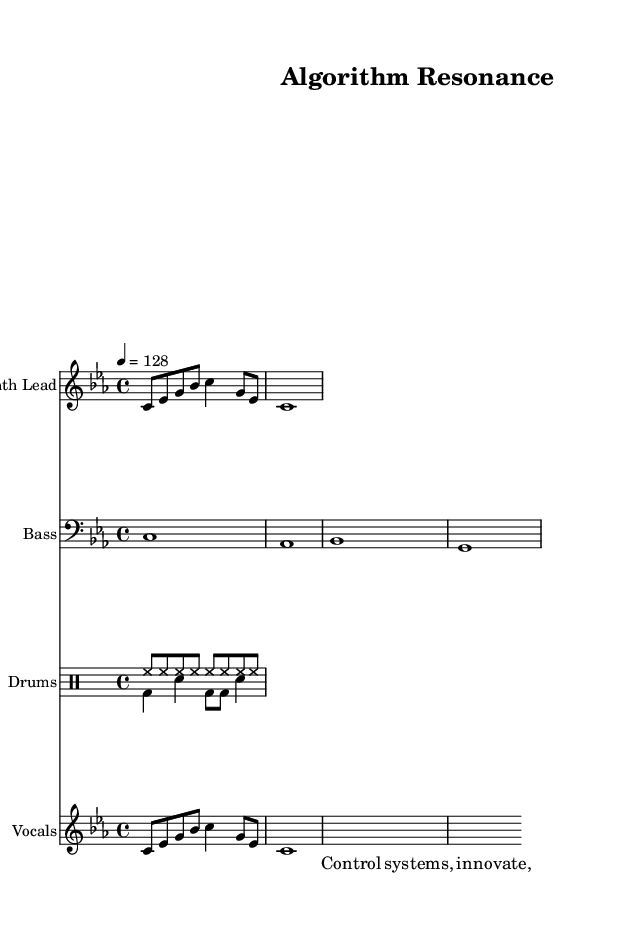What is the key signature of this music? The key signature is indicated by the presence of the flat sign on the B note, suggesting that this piece is in C minor, which has three flats (B♭, E♭, A♭).
Answer: C minor What is the time signature of this music? The time signature appears at the beginning of the score, represented by the notation '4/4', indicating four beats in each measure and a quarter note receives one beat.
Answer: 4/4 What is the tempo marking for this piece? The tempo marking is found in the score with the indication '4 = 128', meaning that there are 128 beats per minute where the quarter note gets the beat.
Answer: 128 How many measures are there in the synth lead? The synth lead section consists of two distinct measures, each with specific note values outlined in the music.
Answer: 2 What type of drum patterns are used in this piece? The score includes two separate drumming sections: 'drumsUp' contains a hi-hat rhythm while 'drumsDown' features a combination of bass drum and snare drum patterns. This highlights a typical house beat structure.
Answer: Hi-hat and bass/snare Which instrument has the main melodic theme? The synth lead, noted as the first entry and contains melody lines, carries the primary theme of this piece, establishing its character in the arrangement.
Answer: Synth Lead What are the lyrics of the robotic vocals? The robotic vocals are displayed directly in the lyrics section, stating both syllabic components and the flow within the measure to complement the rhythm and theme of innovation.
Answer: Control systems, innovate 